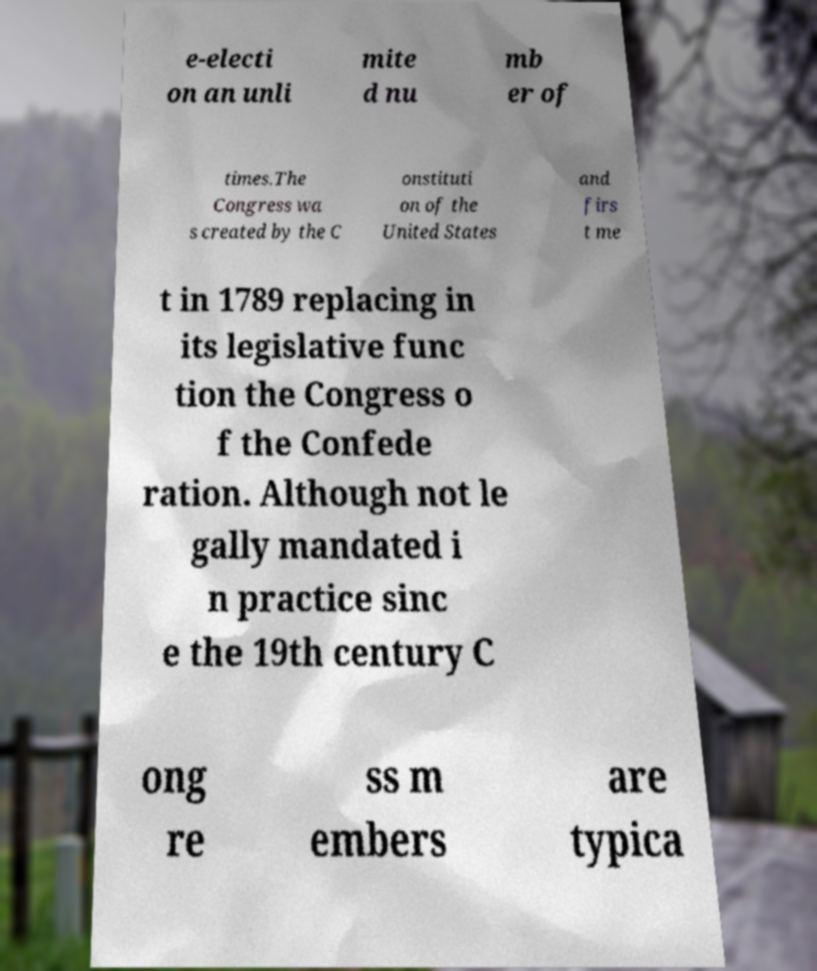Please identify and transcribe the text found in this image. e-electi on an unli mite d nu mb er of times.The Congress wa s created by the C onstituti on of the United States and firs t me t in 1789 replacing in its legislative func tion the Congress o f the Confede ration. Although not le gally mandated i n practice sinc e the 19th century C ong re ss m embers are typica 